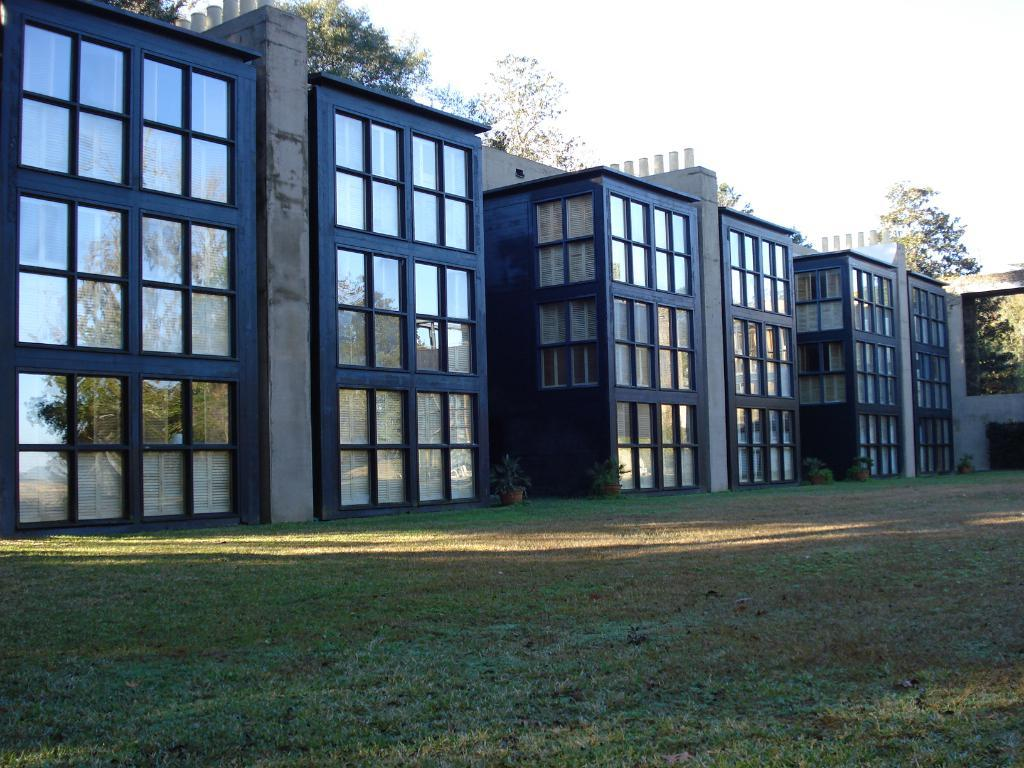What type of vegetation is present at the front of the image? There is grass in the front of the image. What type of structures can be seen in the image? There are buildings in the image. What other natural elements are present in the image? There are trees in the image. What is visible at the top of the image? The sky is visible at the top of the image. Where is the shelf located in the image? There is no shelf present in the image. What note can be seen on the trees in the image? There are no notes present on the trees in the image. 